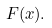<formula> <loc_0><loc_0><loc_500><loc_500>F ( x ) .</formula> 